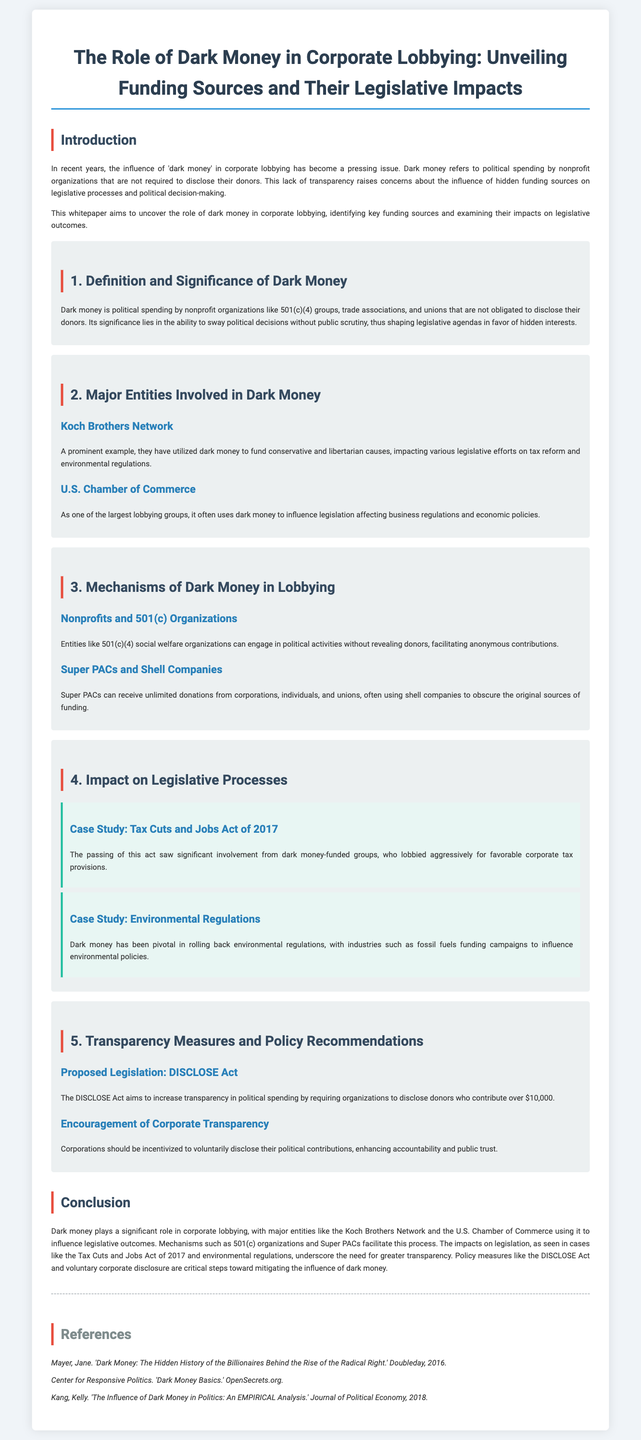What is dark money? Dark money refers to political spending by nonprofit organizations that are not required to disclose their donors.
Answer: Political spending by nonprofit organizations Who are two major entities involved in dark money? The document identifies the Koch Brothers Network and the U.S. Chamber of Commerce as major entities involved in dark money.
Answer: Koch Brothers Network; U.S. Chamber of Commerce What is one mechanism used by dark money in lobbying? The document mentions 501(c)(4) social welfare organizations as a mechanism that can engage in political activities without revealing donors.
Answer: 501(c)(4) social welfare organizations What act seeks to increase transparency in political spending? The DISCLOSE Act aims to increase transparency regarding political spending by requiring organizations to disclose certain donors.
Answer: DISCLOSE Act What significant legislation was influenced by dark money in 2017? The Tax Cuts and Jobs Act of 2017 was significantly influenced by dark money-funded groups according to the case study in the document.
Answer: Tax Cuts and Jobs Act of 2017 What is a proposed policy recommendation for corporations? The document recommends that corporations should be incentivized to voluntarily disclose their political contributions.
Answer: Voluntary disclosure of political contributions What are Super PACs noted for in the document? Super PACs are noted for receiving unlimited donations and often using shell companies to obscure the original sources of funding.
Answer: Receiving unlimited donations What is the purpose of the case studies in the whitepaper? The case studies in the whitepaper illustrate the impact of dark money on specific legislative processes.
Answer: Illustrate the impact on legislative processes 